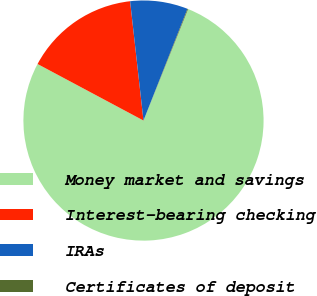Convert chart. <chart><loc_0><loc_0><loc_500><loc_500><pie_chart><fcel>Money market and savings<fcel>Interest-bearing checking<fcel>IRAs<fcel>Certificates of deposit<nl><fcel>76.74%<fcel>15.42%<fcel>7.75%<fcel>0.09%<nl></chart> 